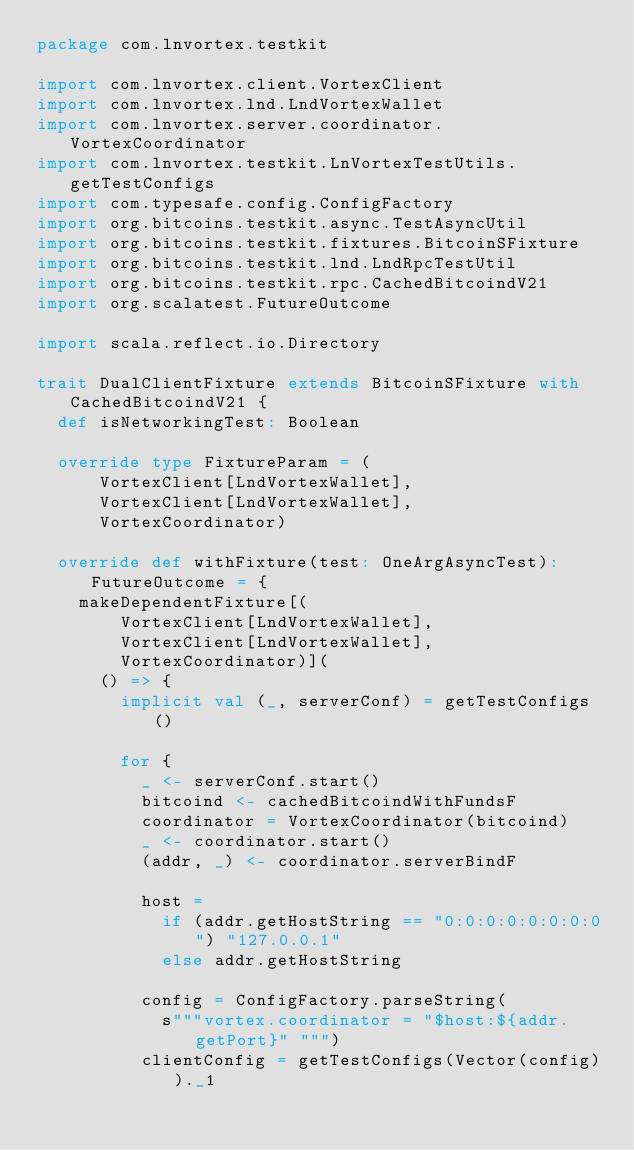Convert code to text. <code><loc_0><loc_0><loc_500><loc_500><_Scala_>package com.lnvortex.testkit

import com.lnvortex.client.VortexClient
import com.lnvortex.lnd.LndVortexWallet
import com.lnvortex.server.coordinator.VortexCoordinator
import com.lnvortex.testkit.LnVortexTestUtils.getTestConfigs
import com.typesafe.config.ConfigFactory
import org.bitcoins.testkit.async.TestAsyncUtil
import org.bitcoins.testkit.fixtures.BitcoinSFixture
import org.bitcoins.testkit.lnd.LndRpcTestUtil
import org.bitcoins.testkit.rpc.CachedBitcoindV21
import org.scalatest.FutureOutcome

import scala.reflect.io.Directory

trait DualClientFixture extends BitcoinSFixture with CachedBitcoindV21 {
  def isNetworkingTest: Boolean

  override type FixtureParam = (
      VortexClient[LndVortexWallet],
      VortexClient[LndVortexWallet],
      VortexCoordinator)

  override def withFixture(test: OneArgAsyncTest): FutureOutcome = {
    makeDependentFixture[(
        VortexClient[LndVortexWallet],
        VortexClient[LndVortexWallet],
        VortexCoordinator)](
      () => {
        implicit val (_, serverConf) = getTestConfigs()

        for {
          _ <- serverConf.start()
          bitcoind <- cachedBitcoindWithFundsF
          coordinator = VortexCoordinator(bitcoind)
          _ <- coordinator.start()
          (addr, _) <- coordinator.serverBindF

          host =
            if (addr.getHostString == "0:0:0:0:0:0:0:0") "127.0.0.1"
            else addr.getHostString

          config = ConfigFactory.parseString(
            s"""vortex.coordinator = "$host:${addr.getPort}" """)
          clientConfig = getTestConfigs(Vector(config))._1
</code> 